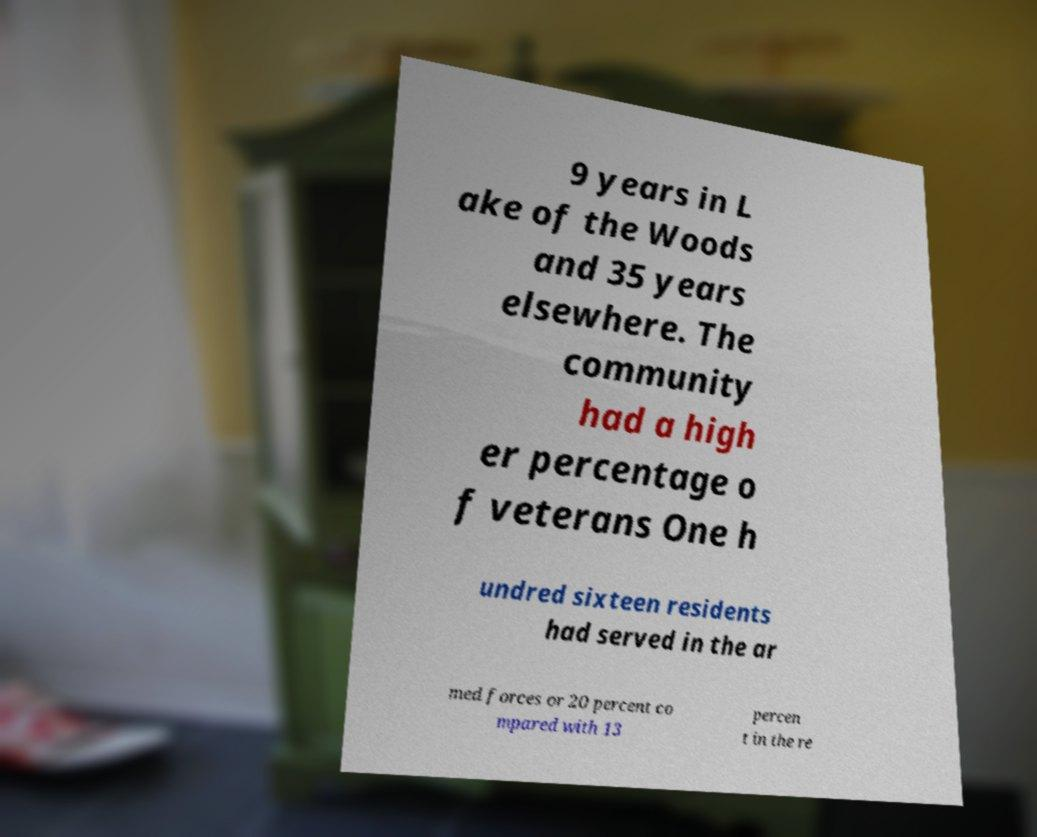Please identify and transcribe the text found in this image. 9 years in L ake of the Woods and 35 years elsewhere. The community had a high er percentage o f veterans One h undred sixteen residents had served in the ar med forces or 20 percent co mpared with 13 percen t in the re 